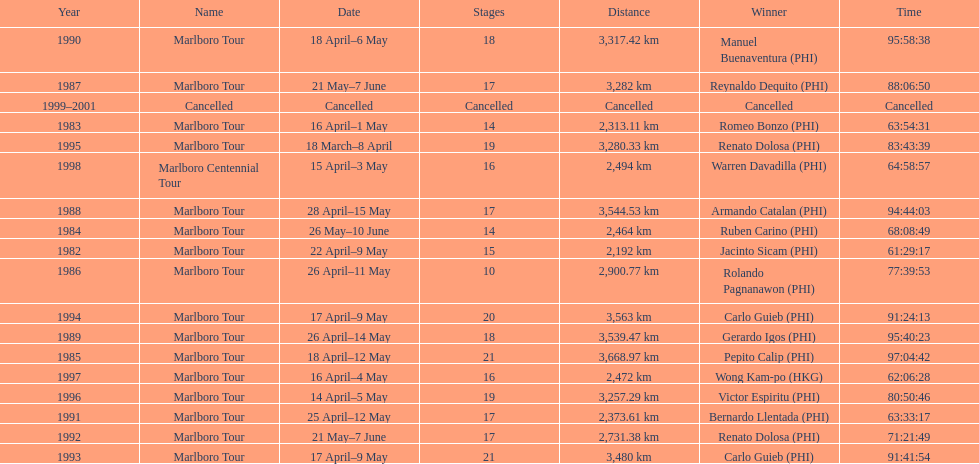Can you give me this table as a dict? {'header': ['Year', 'Name', 'Date', 'Stages', 'Distance', 'Winner', 'Time'], 'rows': [['1990', 'Marlboro Tour', '18 April–6 May', '18', '3,317.42\xa0km', 'Manuel Buenaventura\xa0(PHI)', '95:58:38'], ['1987', 'Marlboro Tour', '21 May–7 June', '17', '3,282\xa0km', 'Reynaldo Dequito\xa0(PHI)', '88:06:50'], ['1999–2001', 'Cancelled', 'Cancelled', 'Cancelled', 'Cancelled', 'Cancelled', 'Cancelled'], ['1983', 'Marlboro Tour', '16 April–1 May', '14', '2,313.11\xa0km', 'Romeo Bonzo\xa0(PHI)', '63:54:31'], ['1995', 'Marlboro Tour', '18 March–8 April', '19', '3,280.33\xa0km', 'Renato Dolosa\xa0(PHI)', '83:43:39'], ['1998', 'Marlboro Centennial Tour', '15 April–3 May', '16', '2,494\xa0km', 'Warren Davadilla\xa0(PHI)', '64:58:57'], ['1988', 'Marlboro Tour', '28 April–15 May', '17', '3,544.53\xa0km', 'Armando Catalan\xa0(PHI)', '94:44:03'], ['1984', 'Marlboro Tour', '26 May–10 June', '14', '2,464\xa0km', 'Ruben Carino\xa0(PHI)', '68:08:49'], ['1982', 'Marlboro Tour', '22 April–9 May', '15', '2,192\xa0km', 'Jacinto Sicam\xa0(PHI)', '61:29:17'], ['1986', 'Marlboro Tour', '26 April–11 May', '10', '2,900.77\xa0km', 'Rolando Pagnanawon\xa0(PHI)', '77:39:53'], ['1994', 'Marlboro Tour', '17 April–9 May', '20', '3,563\xa0km', 'Carlo Guieb\xa0(PHI)', '91:24:13'], ['1989', 'Marlboro Tour', '26 April–14 May', '18', '3,539.47\xa0km', 'Gerardo Igos\xa0(PHI)', '95:40:23'], ['1985', 'Marlboro Tour', '18 April–12 May', '21', '3,668.97\xa0km', 'Pepito Calip\xa0(PHI)', '97:04:42'], ['1997', 'Marlboro Tour', '16 April–4 May', '16', '2,472\xa0km', 'Wong Kam-po\xa0(HKG)', '62:06:28'], ['1996', 'Marlboro Tour', '14 April–5 May', '19', '3,257.29\xa0km', 'Victor Espiritu\xa0(PHI)', '80:50:46'], ['1991', 'Marlboro Tour', '25 April–12 May', '17', '2,373.61\xa0km', 'Bernardo Llentada\xa0(PHI)', '63:33:17'], ['1992', 'Marlboro Tour', '21 May–7 June', '17', '2,731.38\xa0km', 'Renato Dolosa\xa0(PHI)', '71:21:49'], ['1993', 'Marlboro Tour', '17 April–9 May', '21', '3,480\xa0km', 'Carlo Guieb\xa0(PHI)', '91:41:54']]} How long did it take warren davadilla to complete the 1998 marlboro centennial tour? 64:58:57. 